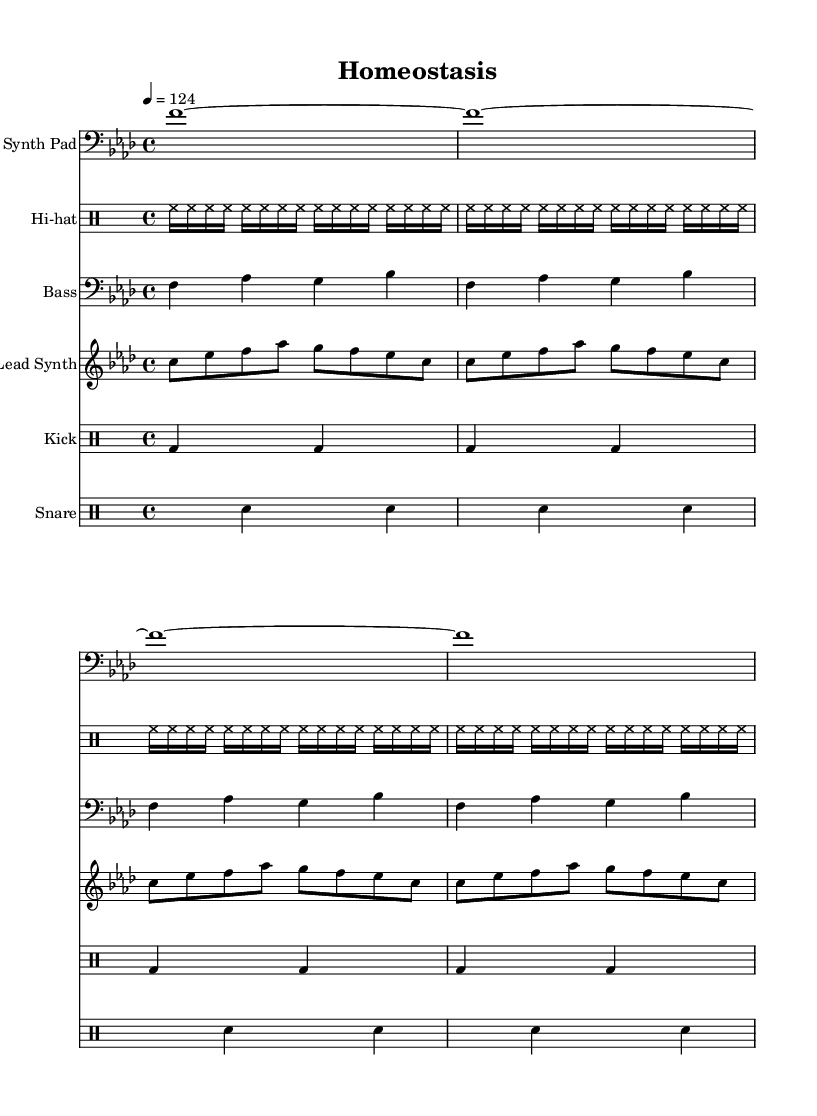What is the key signature of this music? The key signature is indicated at the beginning of the score. In this case, it shows an F minor key, which contains four flats (B♭, E♭, A♭, D♭).
Answer: F minor What is the time signature of this music? The time signature is located next to the key signature at the start. It shows "4/4," meaning there are four beats per measure, and a quarter note gets one beat.
Answer: 4/4 What is the tempo of this piece? The tempo is marked explicitly above the staff in BPM (beats per minute). Here, it shows "4 = 124," meaning the quarter note is played at 124 beats per minute.
Answer: 124 How many measures are in the lead synth part? Counting the repeated sections in the lead synth part shows four measures per line, and there are four lines, resulting in 16 measures in total.
Answer: 16 What instruments are included in this score? The instruments are named explicitly at the top of each staff. The score includes Synth Pad, Hi-hat, Bass, Lead Synth, Kick, and Snare.
Answer: Synth Pad, Hi-hat, Bass, Lead Synth, Kick, Snare Which rhythmic pattern does the kick drum use? The kick drum pattern is indicated in the drum staff. It shows a consistent pattern of bass drum notes and rests, organized in groups of two beats each over four measures.
Answer: Bass drum alternating with rests How is the structure of a typical deep house track reflected in this sheet music? The structure of deep house tracks often features repetitive elements and layers of sounds, as seen in the repeating bass lines, synth pads, and rhythmic drumming patterns throughout the score. This reflects the genre's focus on grooves and atmosphere.
Answer: Repetitive elements and layering 